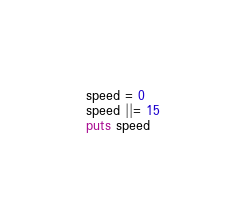Convert code to text. <code><loc_0><loc_0><loc_500><loc_500><_Ruby_>speed = 0
speed ||= 15
puts speed
</code> 